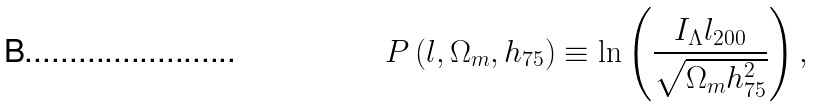<formula> <loc_0><loc_0><loc_500><loc_500>P \left ( l , \Omega _ { m } , h _ { 7 5 } \right ) \equiv \ln \left ( \frac { I _ { \Lambda } l _ { 2 0 0 } } { \sqrt { \Omega _ { m } h _ { 7 5 } ^ { 2 } } } \right ) ,</formula> 